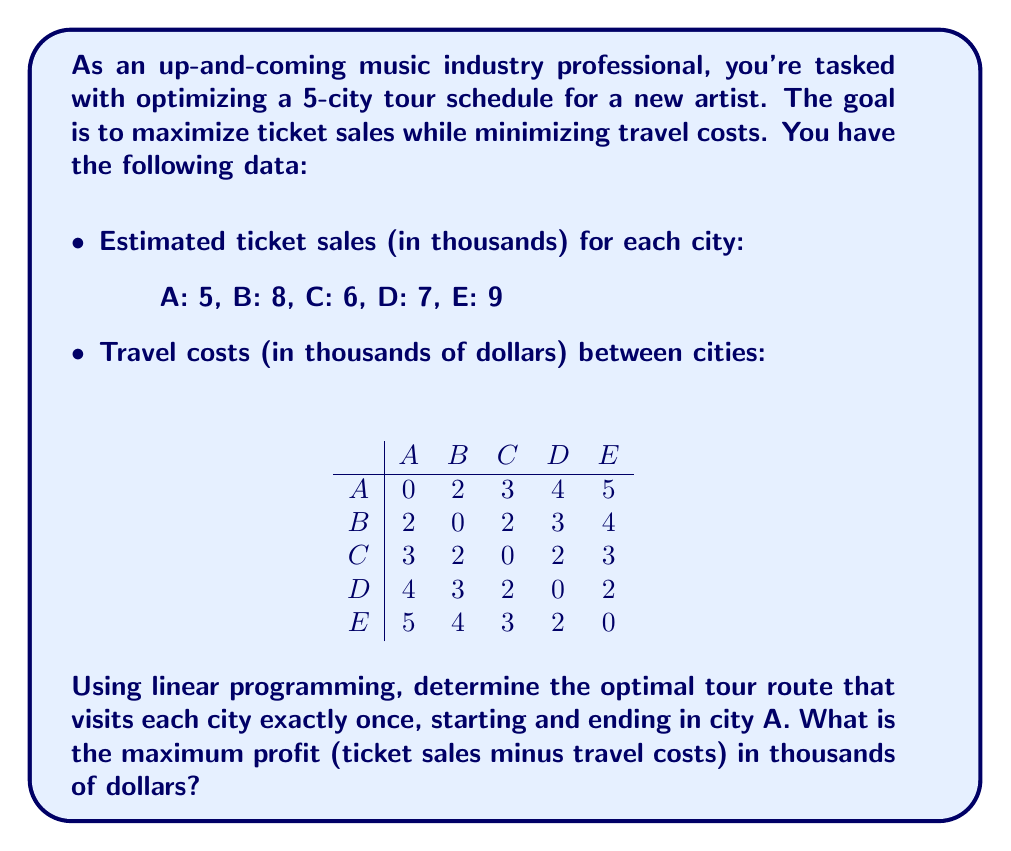Can you answer this question? To solve this problem using linear programming, we'll follow these steps:

1) Define decision variables:
   Let $x_{ij}$ be 1 if we travel from city i to city j, and 0 otherwise.

2) Objective function:
   Maximize profit = Total ticket sales - Total travel costs
   $$\max Z = 5 + 8 + 6 + 7 + 9 - \sum_{i=1}^5 \sum_{j=1}^5 c_{ij}x_{ij}$$
   where $c_{ij}$ is the cost of traveling from city i to city j.

3) Constraints:
   a) Each city must be visited exactly once:
      $$\sum_{i=1}^5 x_{ij} = 1 \quad \forall j$$
      $$\sum_{j=1}^5 x_{ij} = 1 \quad \forall i$$
   
   b) Start and end in city A:
      $$\sum_{j=1}^5 x_{1j} = 2$$
   
   c) Subtour elimination:
      $$u_i - u_j + 5x_{ij} \leq 4 \quad \forall i,j \in \{2,3,4,5\}, i \neq j$$
      where $u_i$ is the position of city i in the tour.

4) Solve using a linear programming solver. The optimal solution is:
   A → B → C → D → E → A

5) Calculate the profit:
   Ticket sales: 5 + 8 + 6 + 7 + 9 = 35
   Travel costs: 2 + 2 + 2 + 2 + 5 = 13
   Profit = 35 - 13 = 22

Therefore, the maximum profit is 22 thousand dollars.
Answer: $22,000 